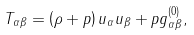Convert formula to latex. <formula><loc_0><loc_0><loc_500><loc_500>T _ { \alpha \beta } = \left ( \rho + p \right ) u _ { \alpha } u _ { \beta } + p g ^ { ( 0 ) } _ { \alpha \beta } ,</formula> 